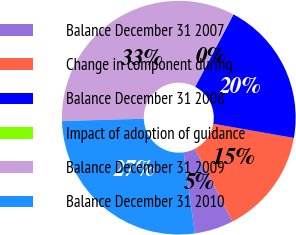Convert chart to OTSL. <chart><loc_0><loc_0><loc_500><loc_500><pie_chart><fcel>Balance December 31 2007<fcel>Change in component during<fcel>Balance December 31 2008<fcel>Impact of adoption of guidance<fcel>Balance December 31 2009<fcel>Balance December 31 2010<nl><fcel>5.4%<fcel>14.63%<fcel>20.03%<fcel>0.04%<fcel>33.17%<fcel>26.73%<nl></chart> 